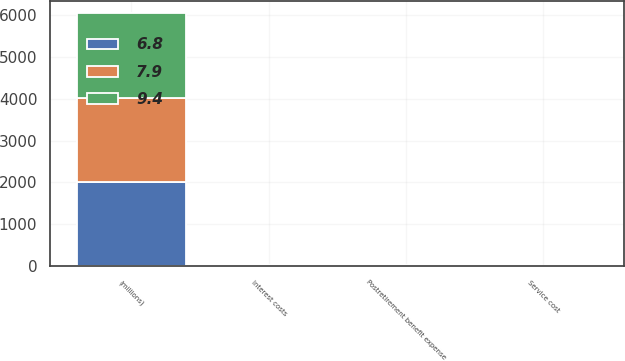Convert chart to OTSL. <chart><loc_0><loc_0><loc_500><loc_500><stacked_bar_chart><ecel><fcel>(millions)<fcel>Service cost<fcel>Interest costs<fcel>Postretirement benefit expense<nl><fcel>9.4<fcel>2015<fcel>3.1<fcel>3.7<fcel>6.8<nl><fcel>7.9<fcel>2014<fcel>3.6<fcel>4.3<fcel>7.9<nl><fcel>6.8<fcel>2013<fcel>5.1<fcel>4.1<fcel>9.4<nl></chart> 